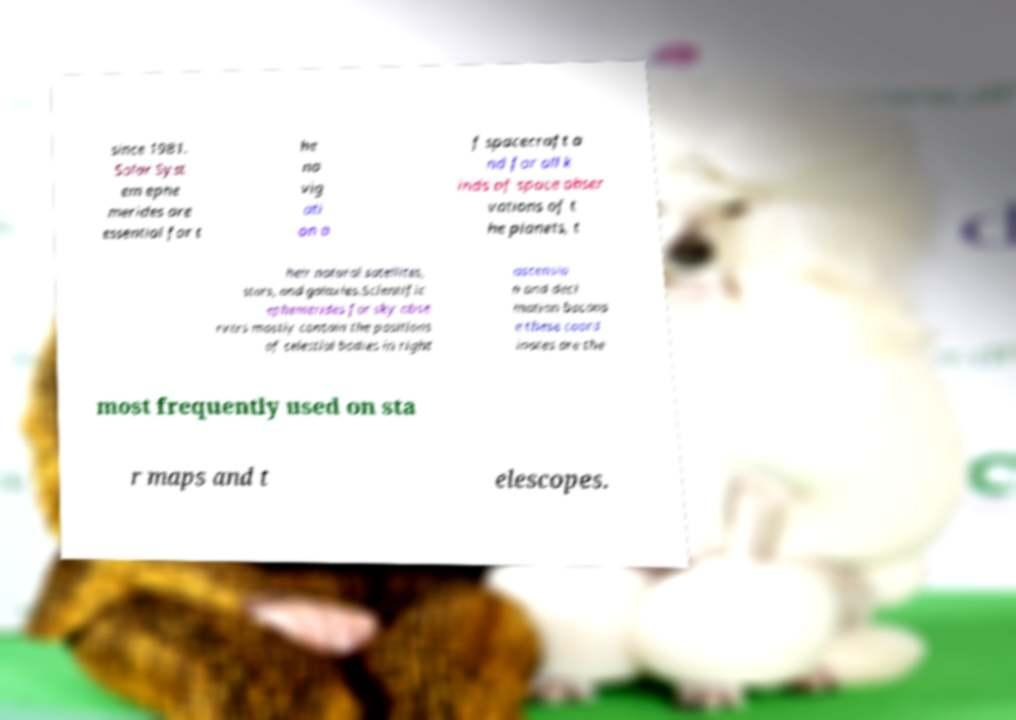What messages or text are displayed in this image? I need them in a readable, typed format. since 1981. Solar Syst em ephe merides are essential for t he na vig ati on o f spacecraft a nd for all k inds of space obser vations of t he planets, t heir natural satellites, stars, and galaxies.Scientific ephemerides for sky obse rvers mostly contain the positions of celestial bodies in right ascensio n and decl ination becaus e these coord inates are the most frequently used on sta r maps and t elescopes. 